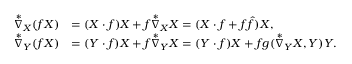Convert formula to latex. <formula><loc_0><loc_0><loc_500><loc_500>\begin{array} { r l } { \overset { * } { \nabla } _ { X } ( f X ) } & { = ( X \cdot f ) X + f \overset { * } { \nabla } _ { X } X = ( X \cdot f + f \hat { f } ) X , } \\ { \overset { * } { \nabla } _ { Y } ( f X ) } & { = ( Y \cdot f ) X + f \overset { * } { \nabla } _ { Y } X = ( Y \cdot f ) X + f g ( \overset { * } { \nabla } _ { Y } X , Y ) Y . } \end{array}</formula> 